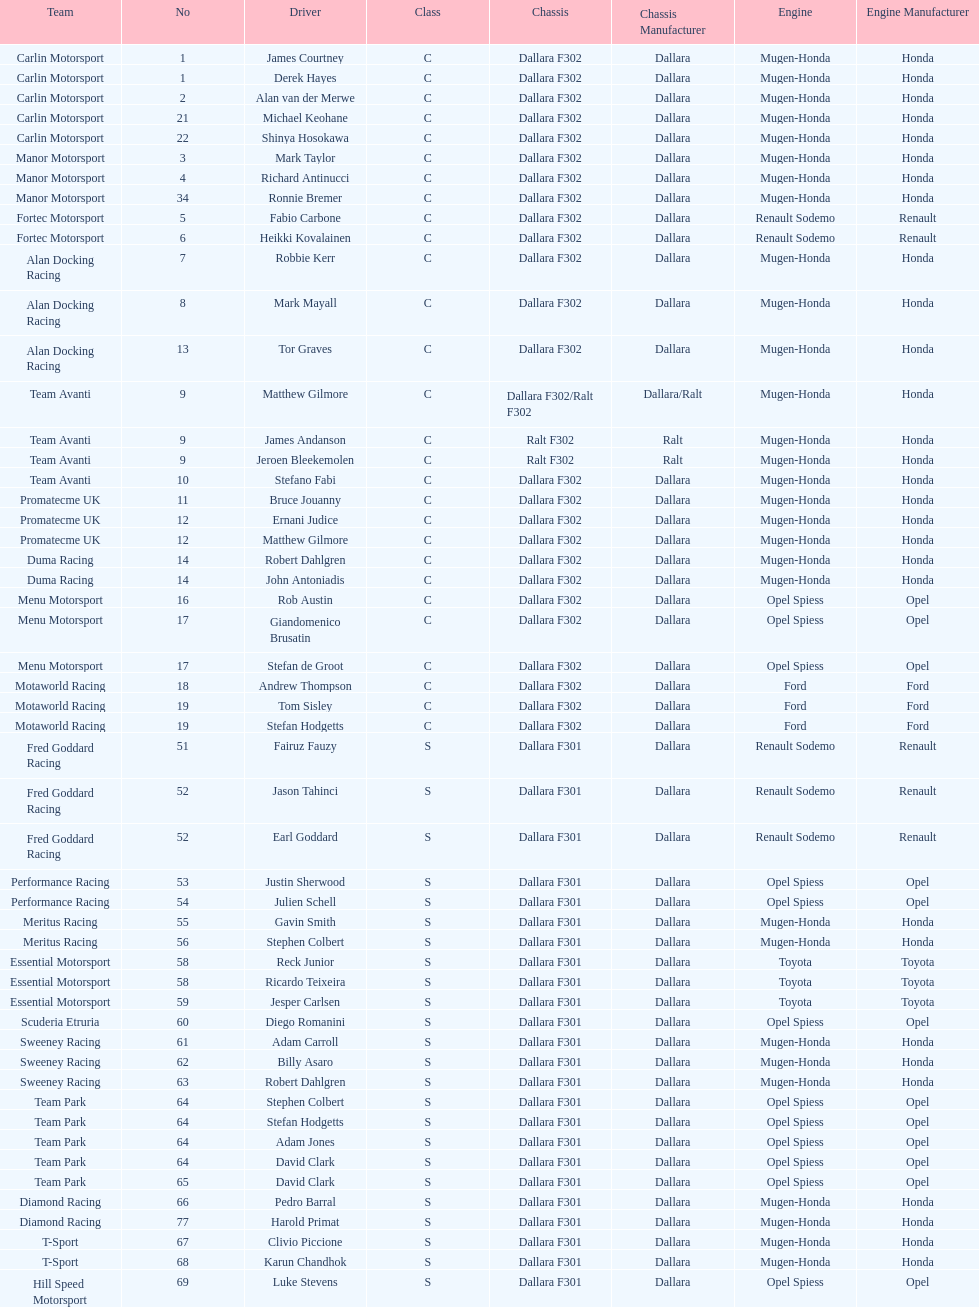How many teams had at least two drivers this season? 17. 